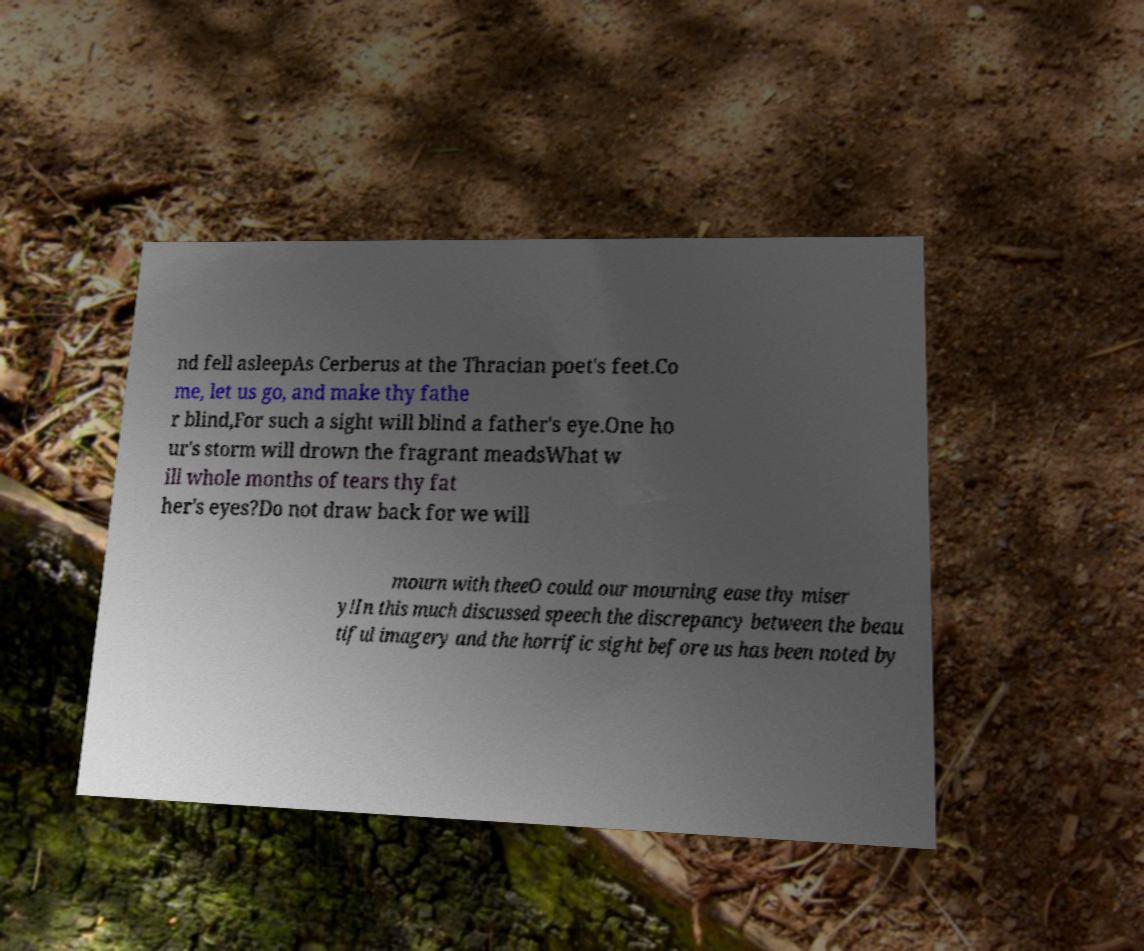There's text embedded in this image that I need extracted. Can you transcribe it verbatim? nd fell asleepAs Cerberus at the Thracian poet's feet.Co me, let us go, and make thy fathe r blind,For such a sight will blind a father's eye.One ho ur's storm will drown the fragrant meadsWhat w ill whole months of tears thy fat her's eyes?Do not draw back for we will mourn with theeO could our mourning ease thy miser y!In this much discussed speech the discrepancy between the beau tiful imagery and the horrific sight before us has been noted by 